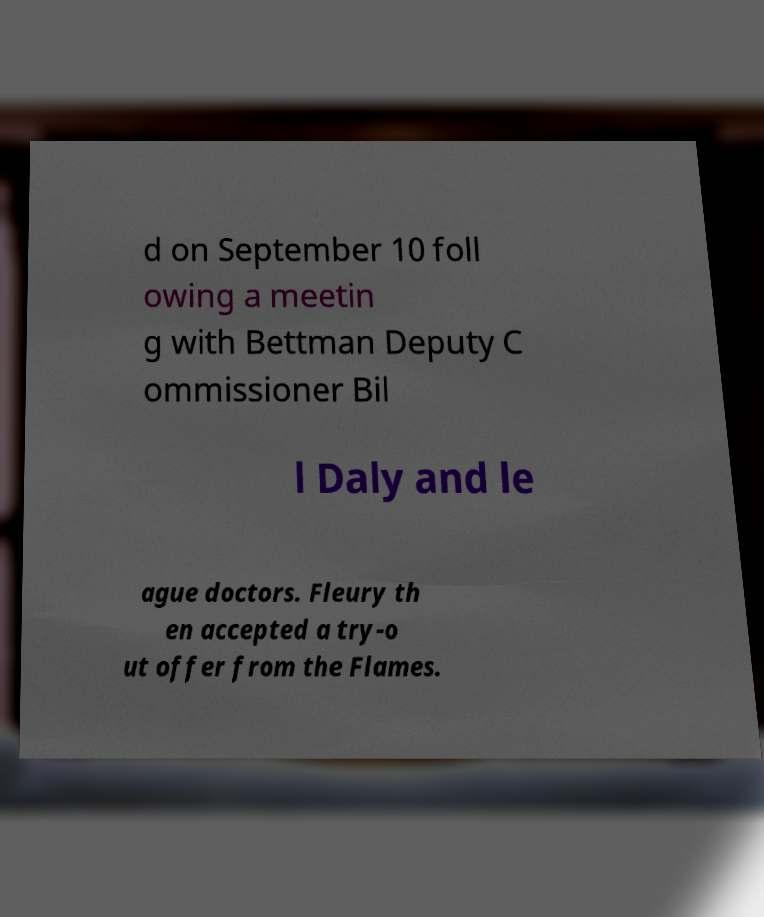What messages or text are displayed in this image? I need them in a readable, typed format. d on September 10 foll owing a meetin g with Bettman Deputy C ommissioner Bil l Daly and le ague doctors. Fleury th en accepted a try-o ut offer from the Flames. 